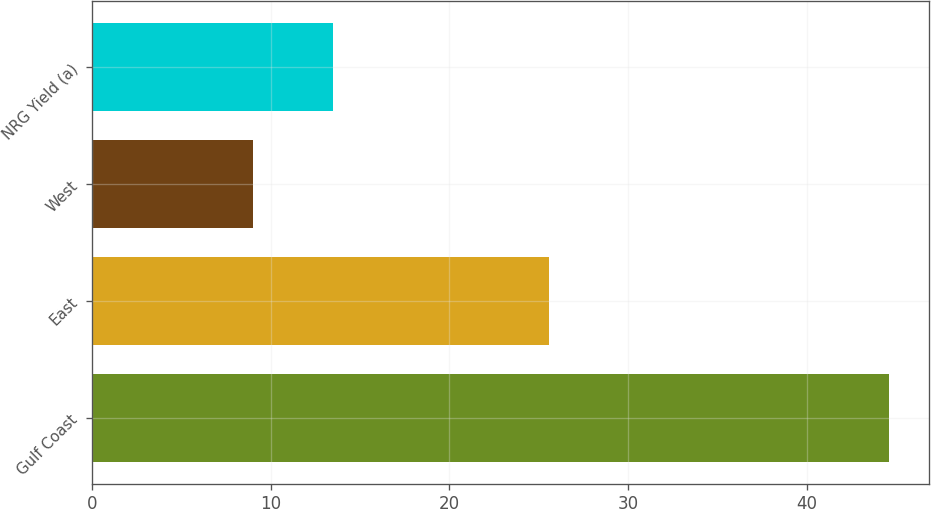<chart> <loc_0><loc_0><loc_500><loc_500><bar_chart><fcel>Gulf Coast<fcel>East<fcel>West<fcel>NRG Yield (a)<nl><fcel>44.6<fcel>25.6<fcel>9<fcel>13.5<nl></chart> 